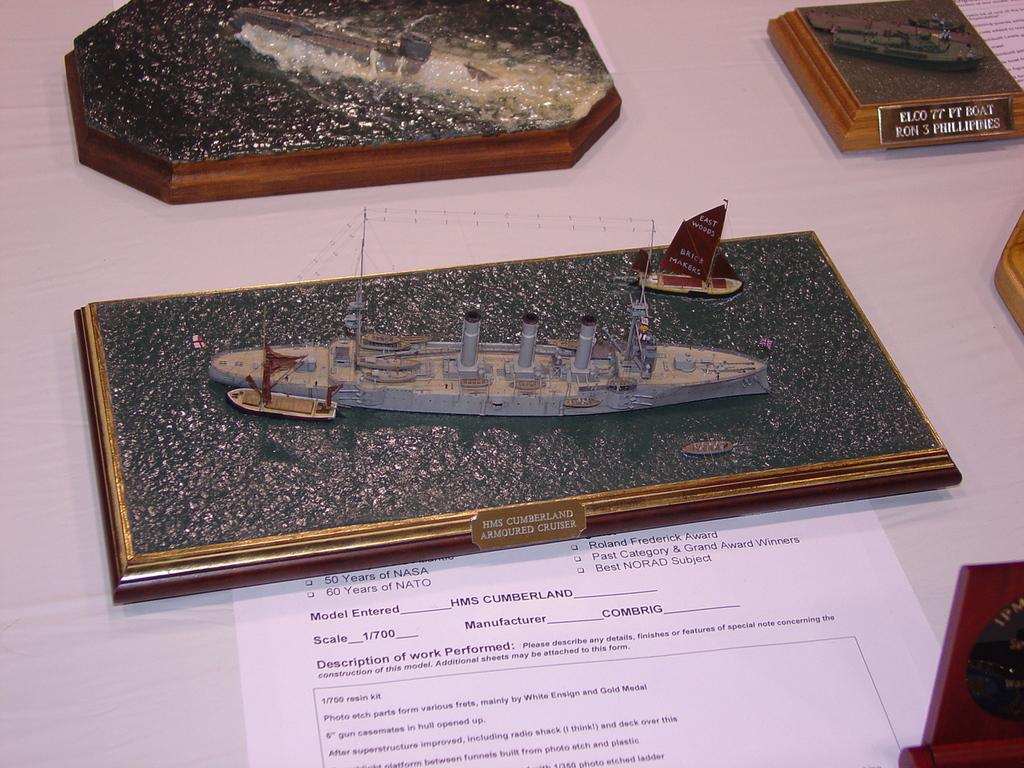What type of objects are featured in the image? There are model ships and boats in the image. How are the model ships and boats arranged? The model ships and boats are arranged on boards. What else can be seen on the table in the image? There are words arranged on a table and a document on the table. How many rings are visible on the model ships in the image? There are no rings visible on the model ships in the image. What type of material is the marble table made of in the image? There is no marble table present in the image. 